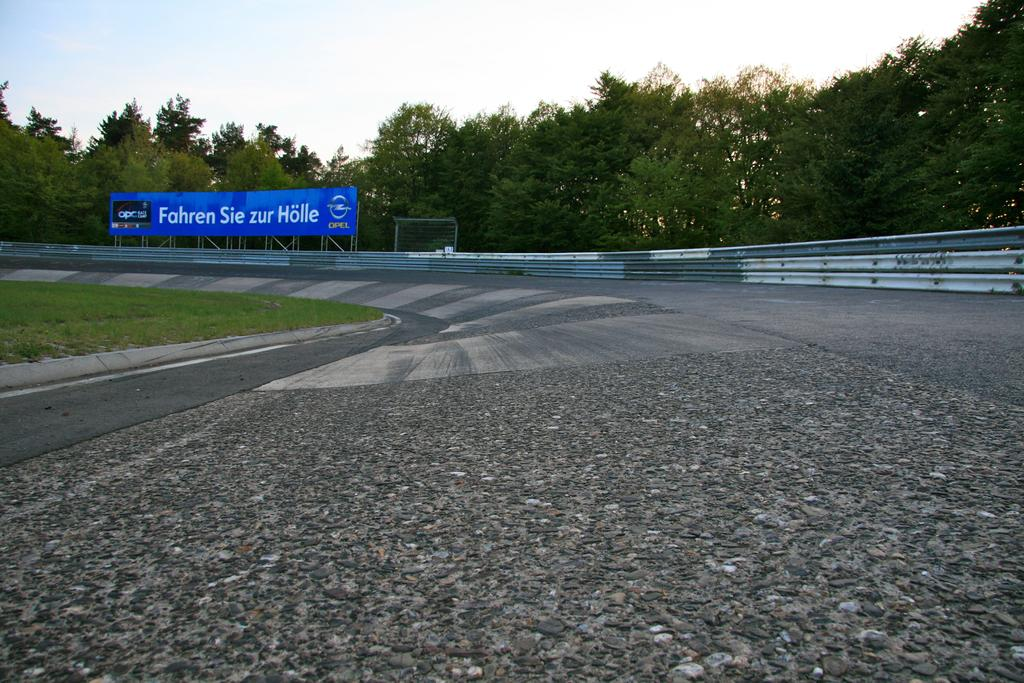<image>
Create a compact narrative representing the image presented. Low perspective of a race track looking forward to a curve with a blue billboard featuring an advertisement written in white. 